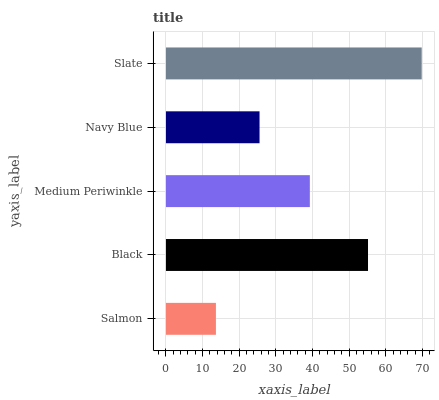Is Salmon the minimum?
Answer yes or no. Yes. Is Slate the maximum?
Answer yes or no. Yes. Is Black the minimum?
Answer yes or no. No. Is Black the maximum?
Answer yes or no. No. Is Black greater than Salmon?
Answer yes or no. Yes. Is Salmon less than Black?
Answer yes or no. Yes. Is Salmon greater than Black?
Answer yes or no. No. Is Black less than Salmon?
Answer yes or no. No. Is Medium Periwinkle the high median?
Answer yes or no. Yes. Is Medium Periwinkle the low median?
Answer yes or no. Yes. Is Navy Blue the high median?
Answer yes or no. No. Is Black the low median?
Answer yes or no. No. 